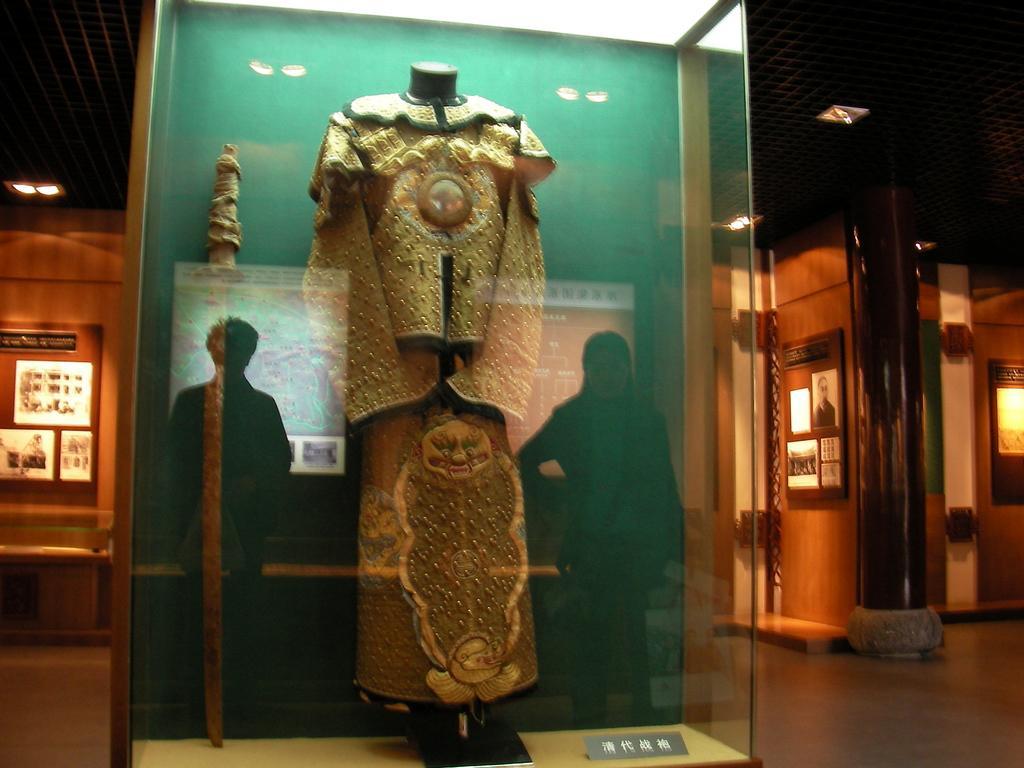Can you describe this image briefly? This picture shows a glass box and we see clothes on the mannequin and a stick on the side and we see reflection of couple of them in the glass and we see few posts and lights to the ceiling. 